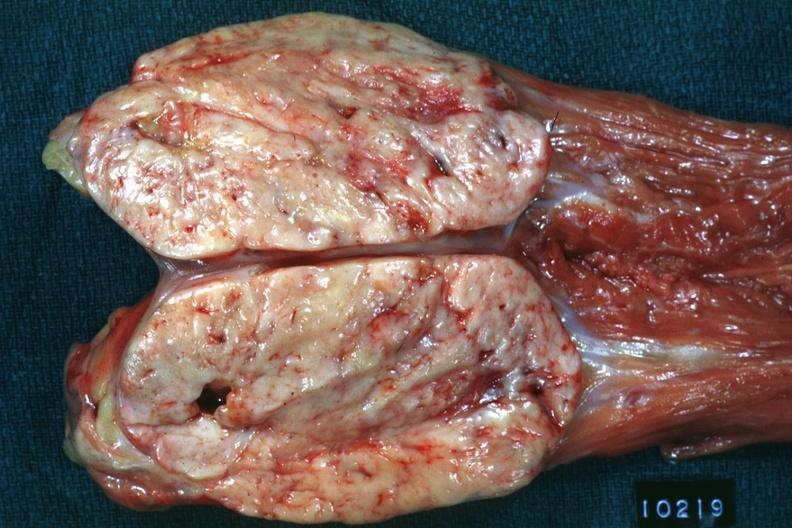where is this area in the body?
Answer the question using a single word or phrase. Abdomen 